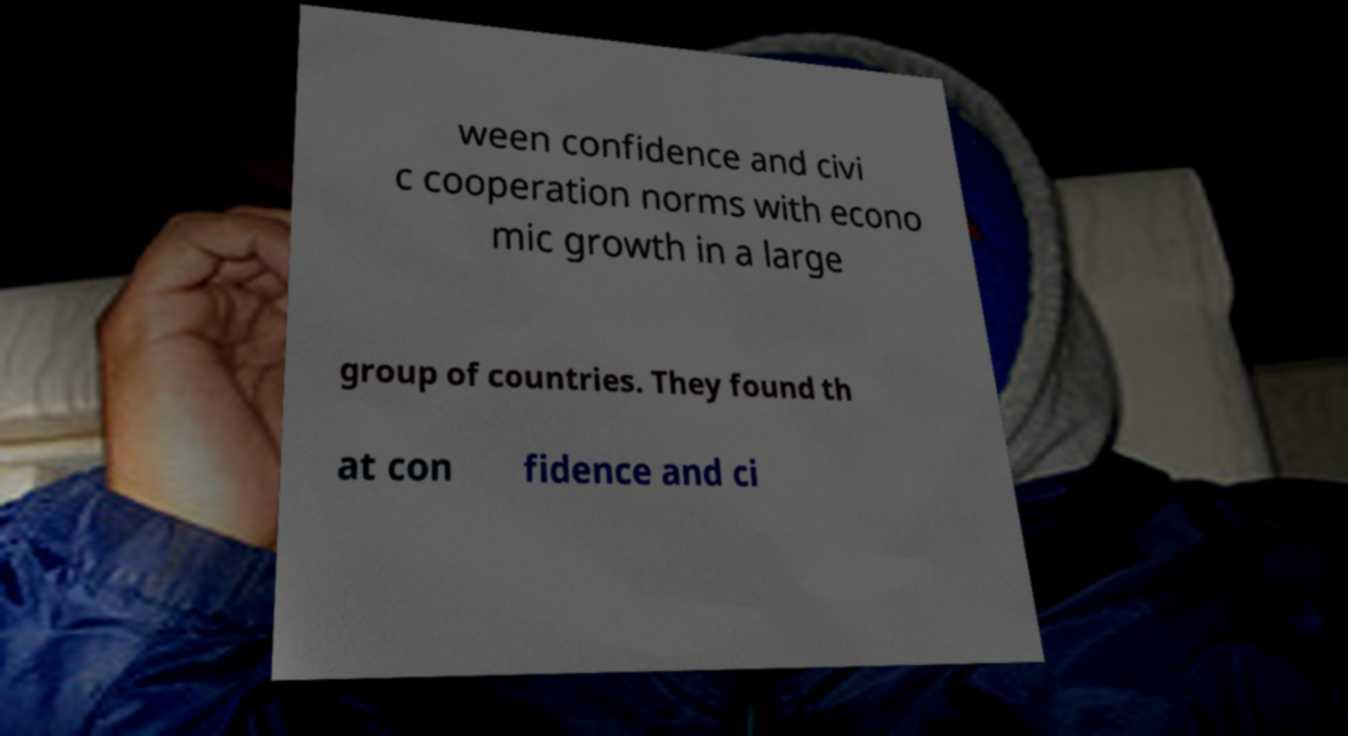Can you read and provide the text displayed in the image?This photo seems to have some interesting text. Can you extract and type it out for me? ween confidence and civi c cooperation norms with econo mic growth in a large group of countries. They found th at con fidence and ci 